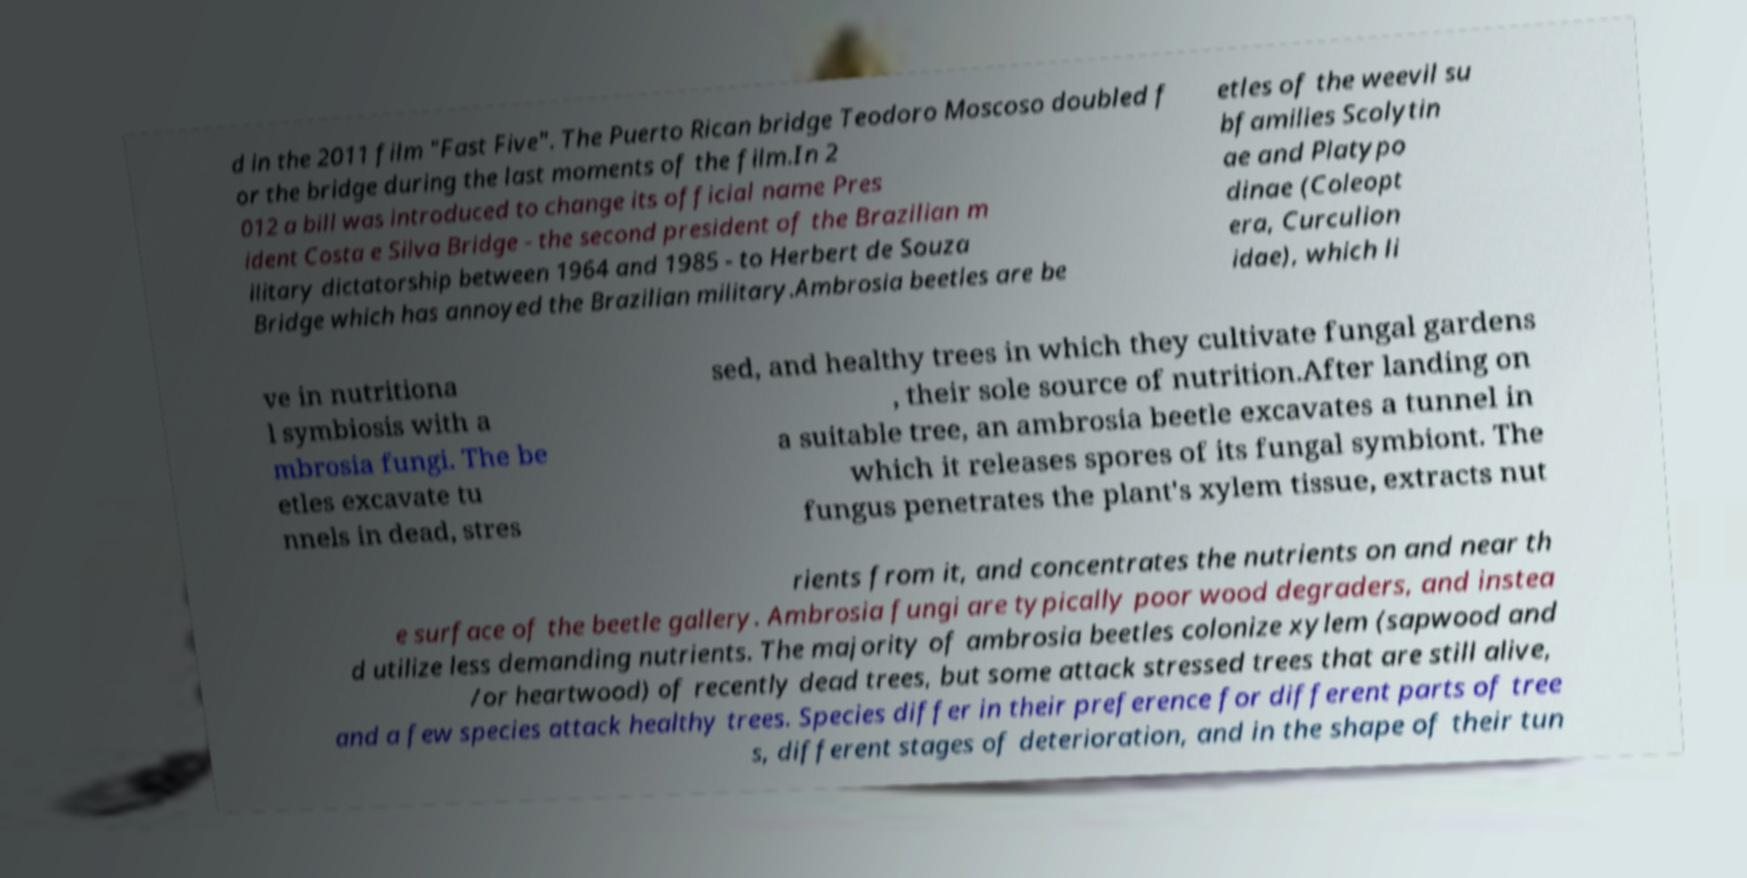Can you accurately transcribe the text from the provided image for me? d in the 2011 film "Fast Five". The Puerto Rican bridge Teodoro Moscoso doubled f or the bridge during the last moments of the film.In 2 012 a bill was introduced to change its official name Pres ident Costa e Silva Bridge - the second president of the Brazilian m ilitary dictatorship between 1964 and 1985 - to Herbert de Souza Bridge which has annoyed the Brazilian military.Ambrosia beetles are be etles of the weevil su bfamilies Scolytin ae and Platypo dinae (Coleopt era, Curculion idae), which li ve in nutritiona l symbiosis with a mbrosia fungi. The be etles excavate tu nnels in dead, stres sed, and healthy trees in which they cultivate fungal gardens , their sole source of nutrition.After landing on a suitable tree, an ambrosia beetle excavates a tunnel in which it releases spores of its fungal symbiont. The fungus penetrates the plant's xylem tissue, extracts nut rients from it, and concentrates the nutrients on and near th e surface of the beetle gallery. Ambrosia fungi are typically poor wood degraders, and instea d utilize less demanding nutrients. The majority of ambrosia beetles colonize xylem (sapwood and /or heartwood) of recently dead trees, but some attack stressed trees that are still alive, and a few species attack healthy trees. Species differ in their preference for different parts of tree s, different stages of deterioration, and in the shape of their tun 